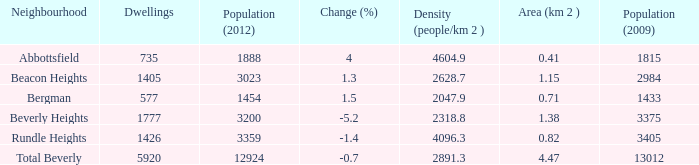How many Dwellings does Beverly Heights have that have a change percent larger than -5.2? None. 